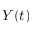Convert formula to latex. <formula><loc_0><loc_0><loc_500><loc_500>Y ( t )</formula> 